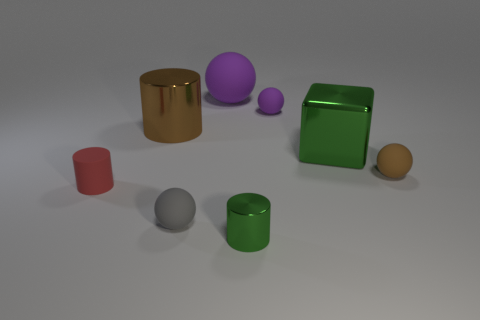Subtract all big purple matte balls. How many balls are left? 3 Subtract all cyan cylinders. How many purple balls are left? 2 Subtract all blocks. How many objects are left? 7 Add 1 green cubes. How many objects exist? 9 Subtract 2 balls. How many balls are left? 2 Subtract all purple spheres. How many spheres are left? 2 Subtract all big objects. Subtract all small brown matte spheres. How many objects are left? 4 Add 3 big brown metallic cylinders. How many big brown metallic cylinders are left? 4 Add 8 big matte blocks. How many big matte blocks exist? 8 Subtract 0 gray cylinders. How many objects are left? 8 